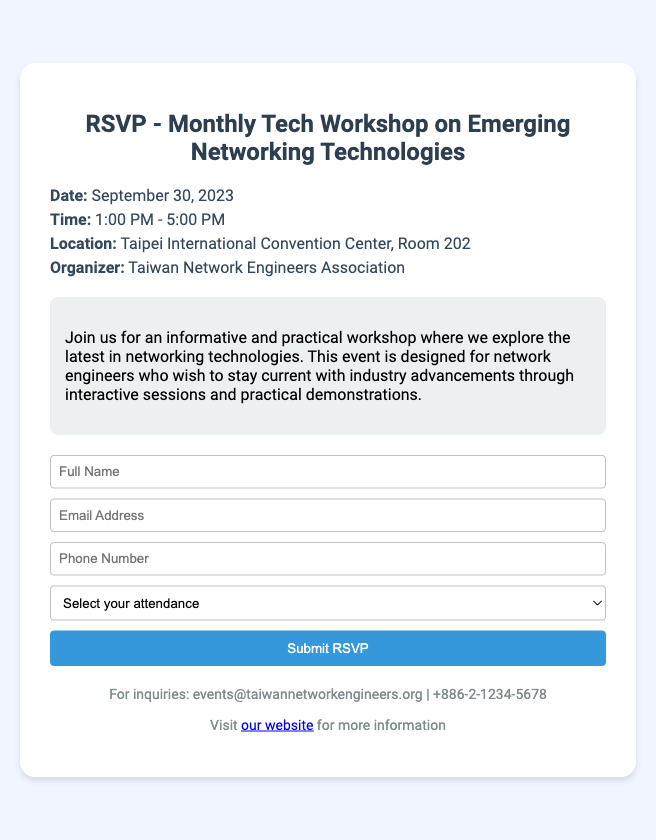what is the date of the workshop? The date of the workshop is specifically mentioned in the document under the information section.
Answer: September 30, 2023 what time does the workshop start? The starting time is clearly stated in the document as part of the event details.
Answer: 1:00 PM where is the workshop being held? The location of the workshop is specified in the information section of the document.
Answer: Taipei International Convention Center, Room 202 who is organizing the event? The organizer of the workshop is listed in the document, indicating who is responsible for the event.
Answer: Taiwan Network Engineers Association what is the purpose of the workshop? The purpose of the workshop can be inferred from the description provided in the document.
Answer: Explore the latest in networking technologies how long is the workshop scheduled for? The total duration can be determined by subtracting the start time from the end time mentioned in the document.
Answer: 4 hours what information do I need to provide when RSVP? The RSVP form indicates the information required for participants to register for the event.
Answer: Full Name, Email Address, Phone Number, Attendance what options do attendees have for attendance? The attendance options are listed in the RSVP form of the document.
Answer: Yes, I will attend; No, I cannot attend 